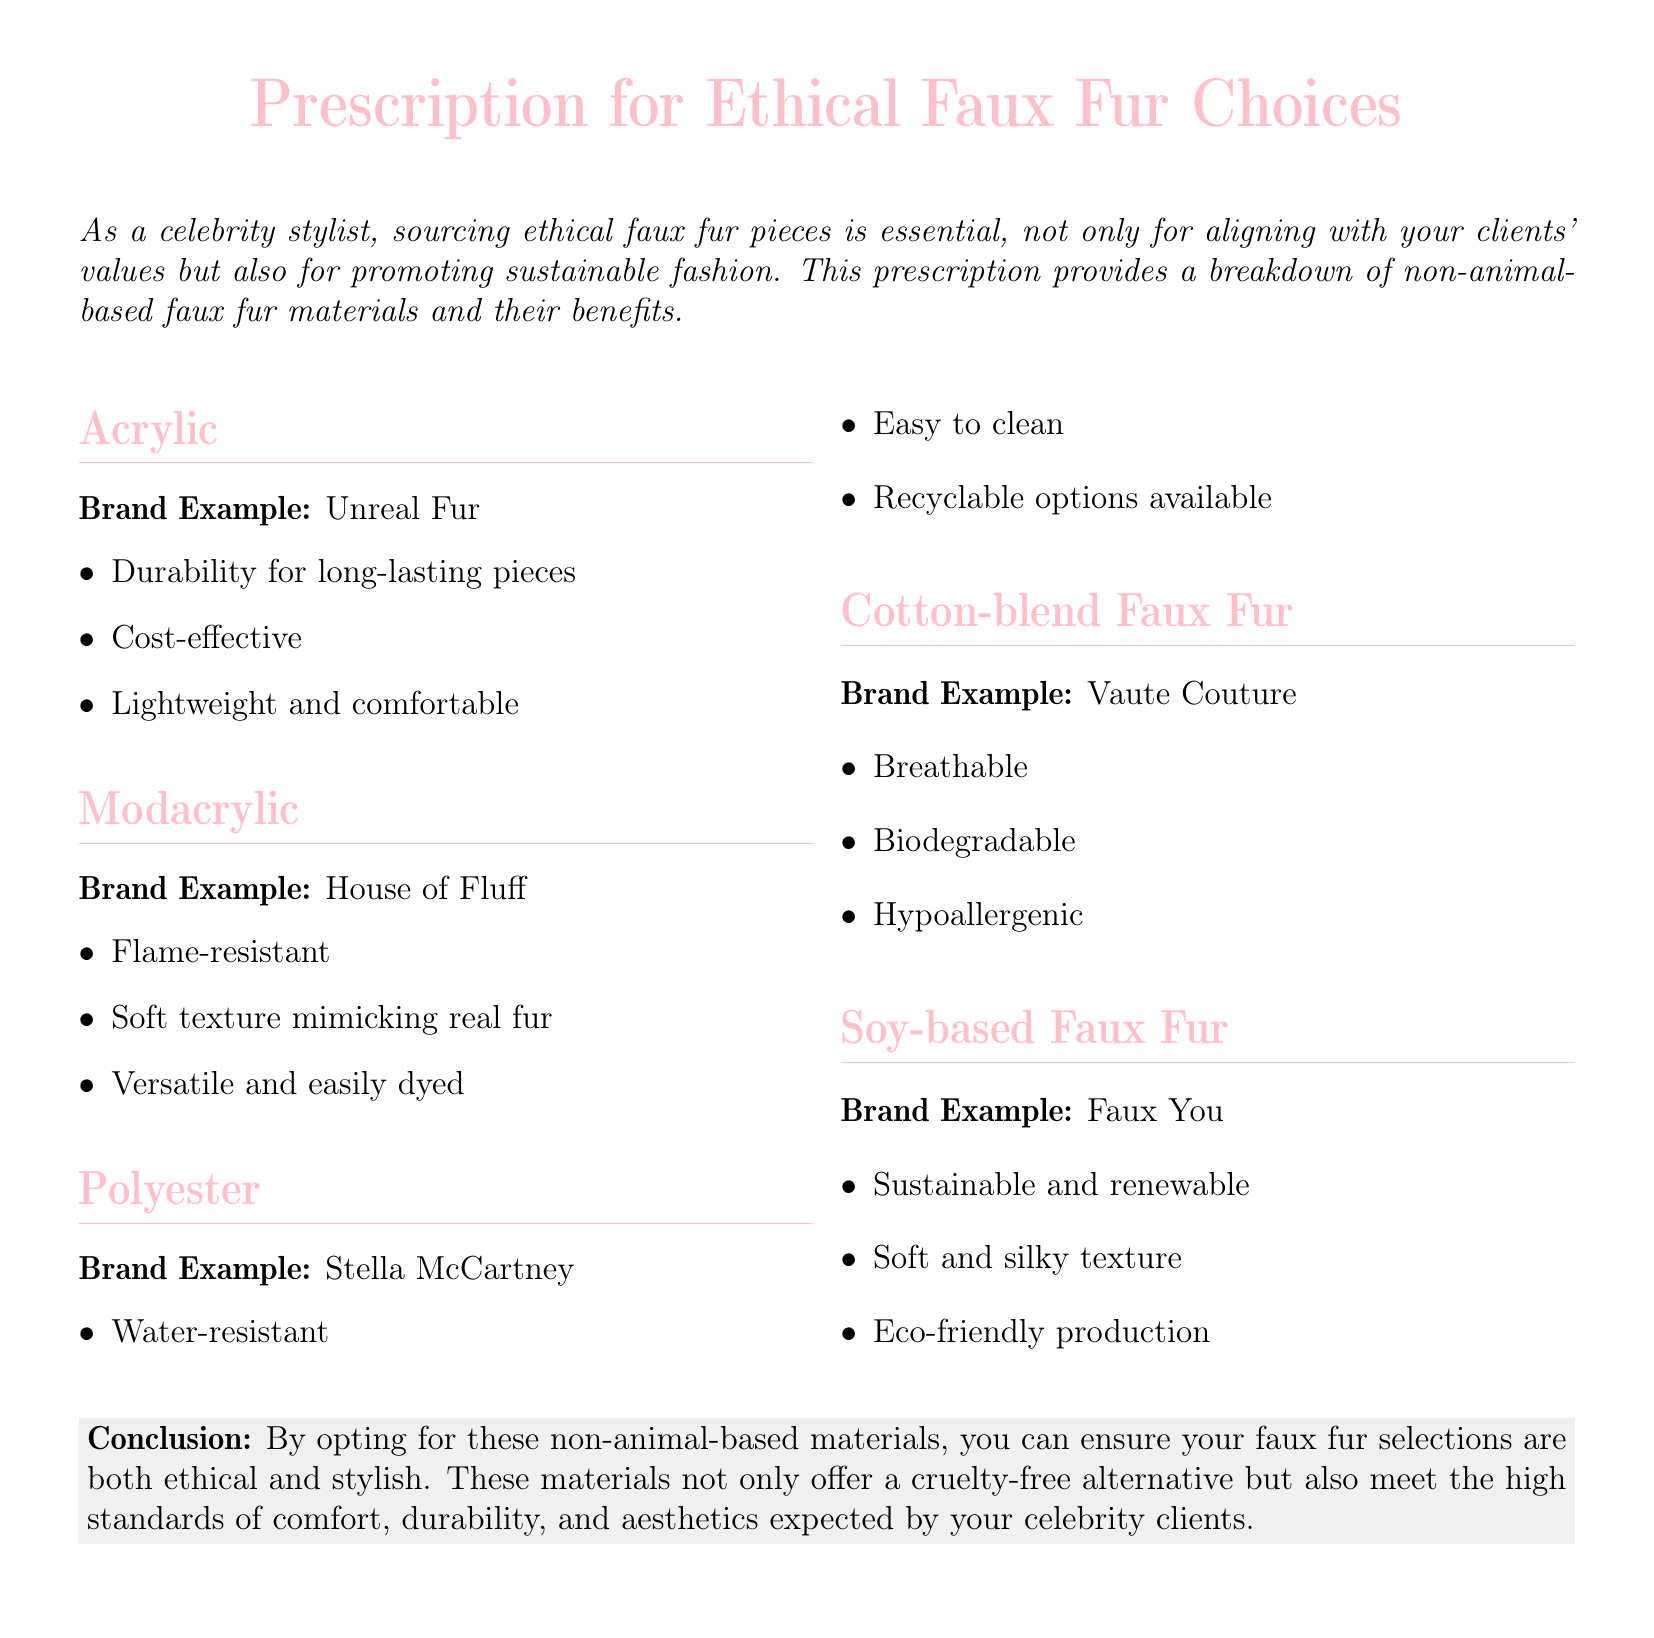What material is associated with Unreal Fur? Unreal Fur is an example brand for Acrylic, which is mentioned in the document.
Answer: Acrylic Which faux fur material is flame-resistant? The document lists Modacrylic as the material that is flame-resistant.
Answer: Modacrylic What is a key benefit of polyester faux fur? The document indicates that polyester is water-resistant, making it a key benefit.
Answer: Water-resistant Which brand produces cotton-blend faux fur? Vaute Couture is identified as the brand associated with cotton-blend faux fur in the document.
Answer: Vaute Couture What texture does soy-based faux fur have? The document states that soy-based faux fur has a soft and silky texture.
Answer: Soft and silky What are the benefits of using non-animal-based materials according to the conclusion? The conclusion highlights that non-animal-based materials offer a cruelty-free alternative and meet comfort, durability, and aesthetics standards.
Answer: Ethical and stylish How many non-animal-based materials are listed in the document? The document lists a total of five non-animal-based materials.
Answer: Five What is a benefit of using cotton-blend faux fur? The document mentions that cotton-blend faux fur is breathable, among its benefits.
Answer: Breathable What does the conclusion emphasize about the selections made? The conclusion emphasizes that by opting for non-animal-based materials, selections will be ethical and stylish.
Answer: Ethical and stylish 